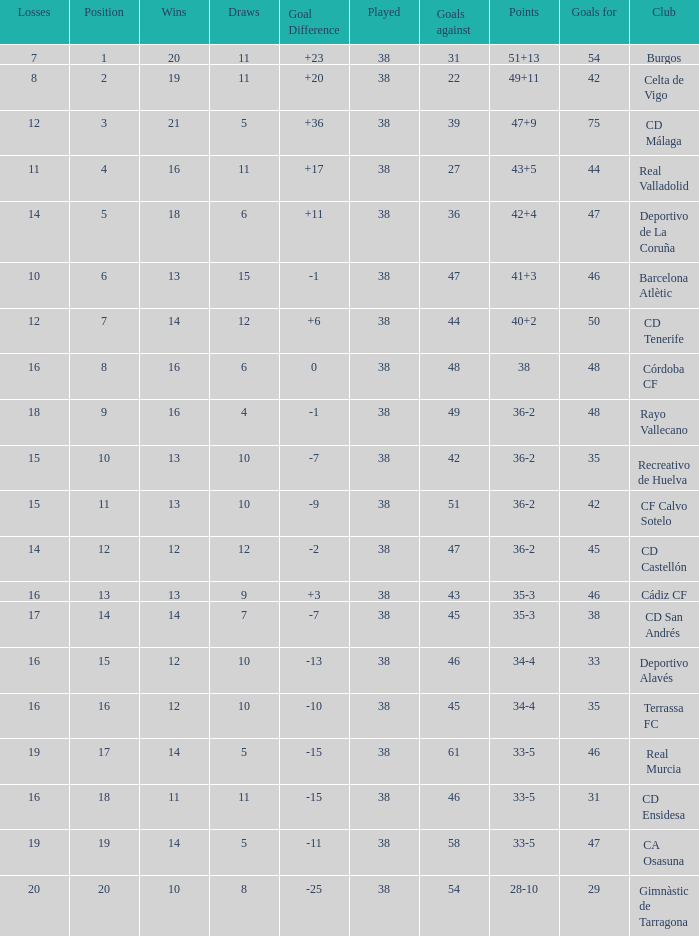What is the average loss with a goal higher than 51 and wins higher than 14? None. 